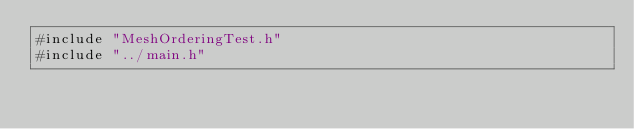Convert code to text. <code><loc_0><loc_0><loc_500><loc_500><_Cuda_>#include "MeshOrderingTest.h"
#include "../main.h"
</code> 